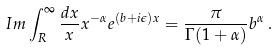Convert formula to latex. <formula><loc_0><loc_0><loc_500><loc_500>I m \int _ { R } ^ { \infty } \frac { d x } { x } x ^ { - \alpha } e ^ { ( b + i \epsilon ) x } = \frac { \pi } { \Gamma ( 1 + \alpha ) } b ^ { \alpha } \, .</formula> 